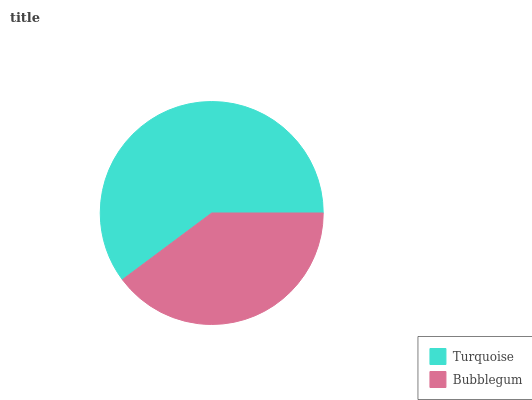Is Bubblegum the minimum?
Answer yes or no. Yes. Is Turquoise the maximum?
Answer yes or no. Yes. Is Bubblegum the maximum?
Answer yes or no. No. Is Turquoise greater than Bubblegum?
Answer yes or no. Yes. Is Bubblegum less than Turquoise?
Answer yes or no. Yes. Is Bubblegum greater than Turquoise?
Answer yes or no. No. Is Turquoise less than Bubblegum?
Answer yes or no. No. Is Turquoise the high median?
Answer yes or no. Yes. Is Bubblegum the low median?
Answer yes or no. Yes. Is Bubblegum the high median?
Answer yes or no. No. Is Turquoise the low median?
Answer yes or no. No. 